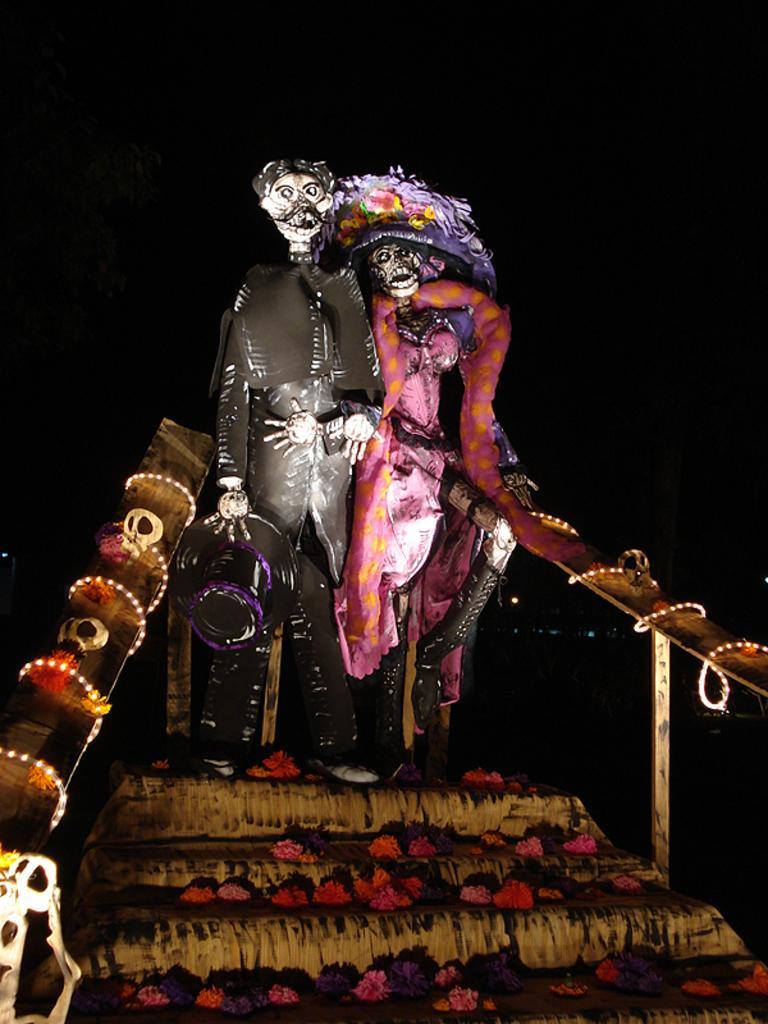In one or two sentences, can you explain what this image depicts? In this image there are two scarecrows standing on the steps. There are wooden sticks on either side of them. There are flowers on the steps. 